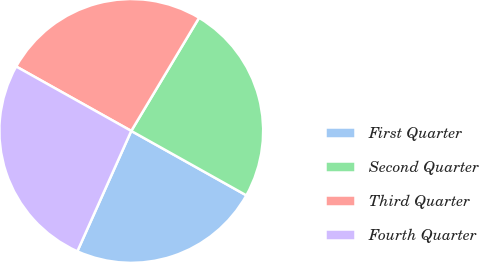Convert chart to OTSL. <chart><loc_0><loc_0><loc_500><loc_500><pie_chart><fcel>First Quarter<fcel>Second Quarter<fcel>Third Quarter<fcel>Fourth Quarter<nl><fcel>23.58%<fcel>24.53%<fcel>25.47%<fcel>26.42%<nl></chart> 